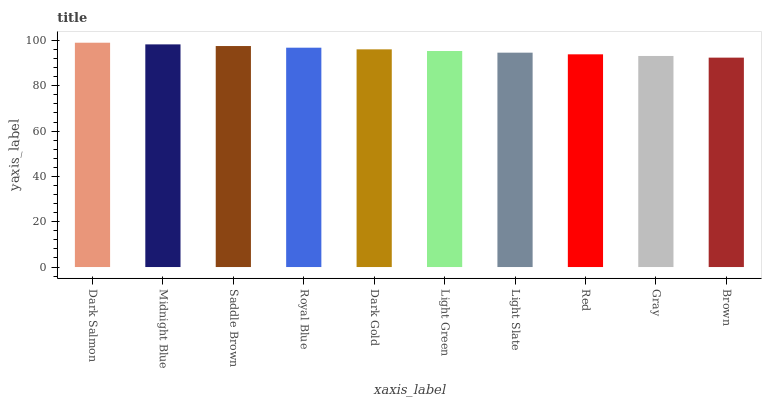Is Brown the minimum?
Answer yes or no. Yes. Is Dark Salmon the maximum?
Answer yes or no. Yes. Is Midnight Blue the minimum?
Answer yes or no. No. Is Midnight Blue the maximum?
Answer yes or no. No. Is Dark Salmon greater than Midnight Blue?
Answer yes or no. Yes. Is Midnight Blue less than Dark Salmon?
Answer yes or no. Yes. Is Midnight Blue greater than Dark Salmon?
Answer yes or no. No. Is Dark Salmon less than Midnight Blue?
Answer yes or no. No. Is Dark Gold the high median?
Answer yes or no. Yes. Is Light Green the low median?
Answer yes or no. Yes. Is Light Slate the high median?
Answer yes or no. No. Is Red the low median?
Answer yes or no. No. 